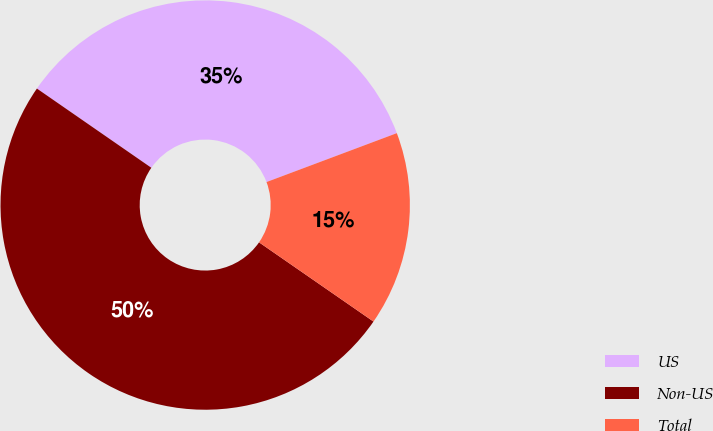Convert chart. <chart><loc_0><loc_0><loc_500><loc_500><pie_chart><fcel>US<fcel>Non-US<fcel>Total<nl><fcel>34.65%<fcel>50.0%<fcel>15.35%<nl></chart> 